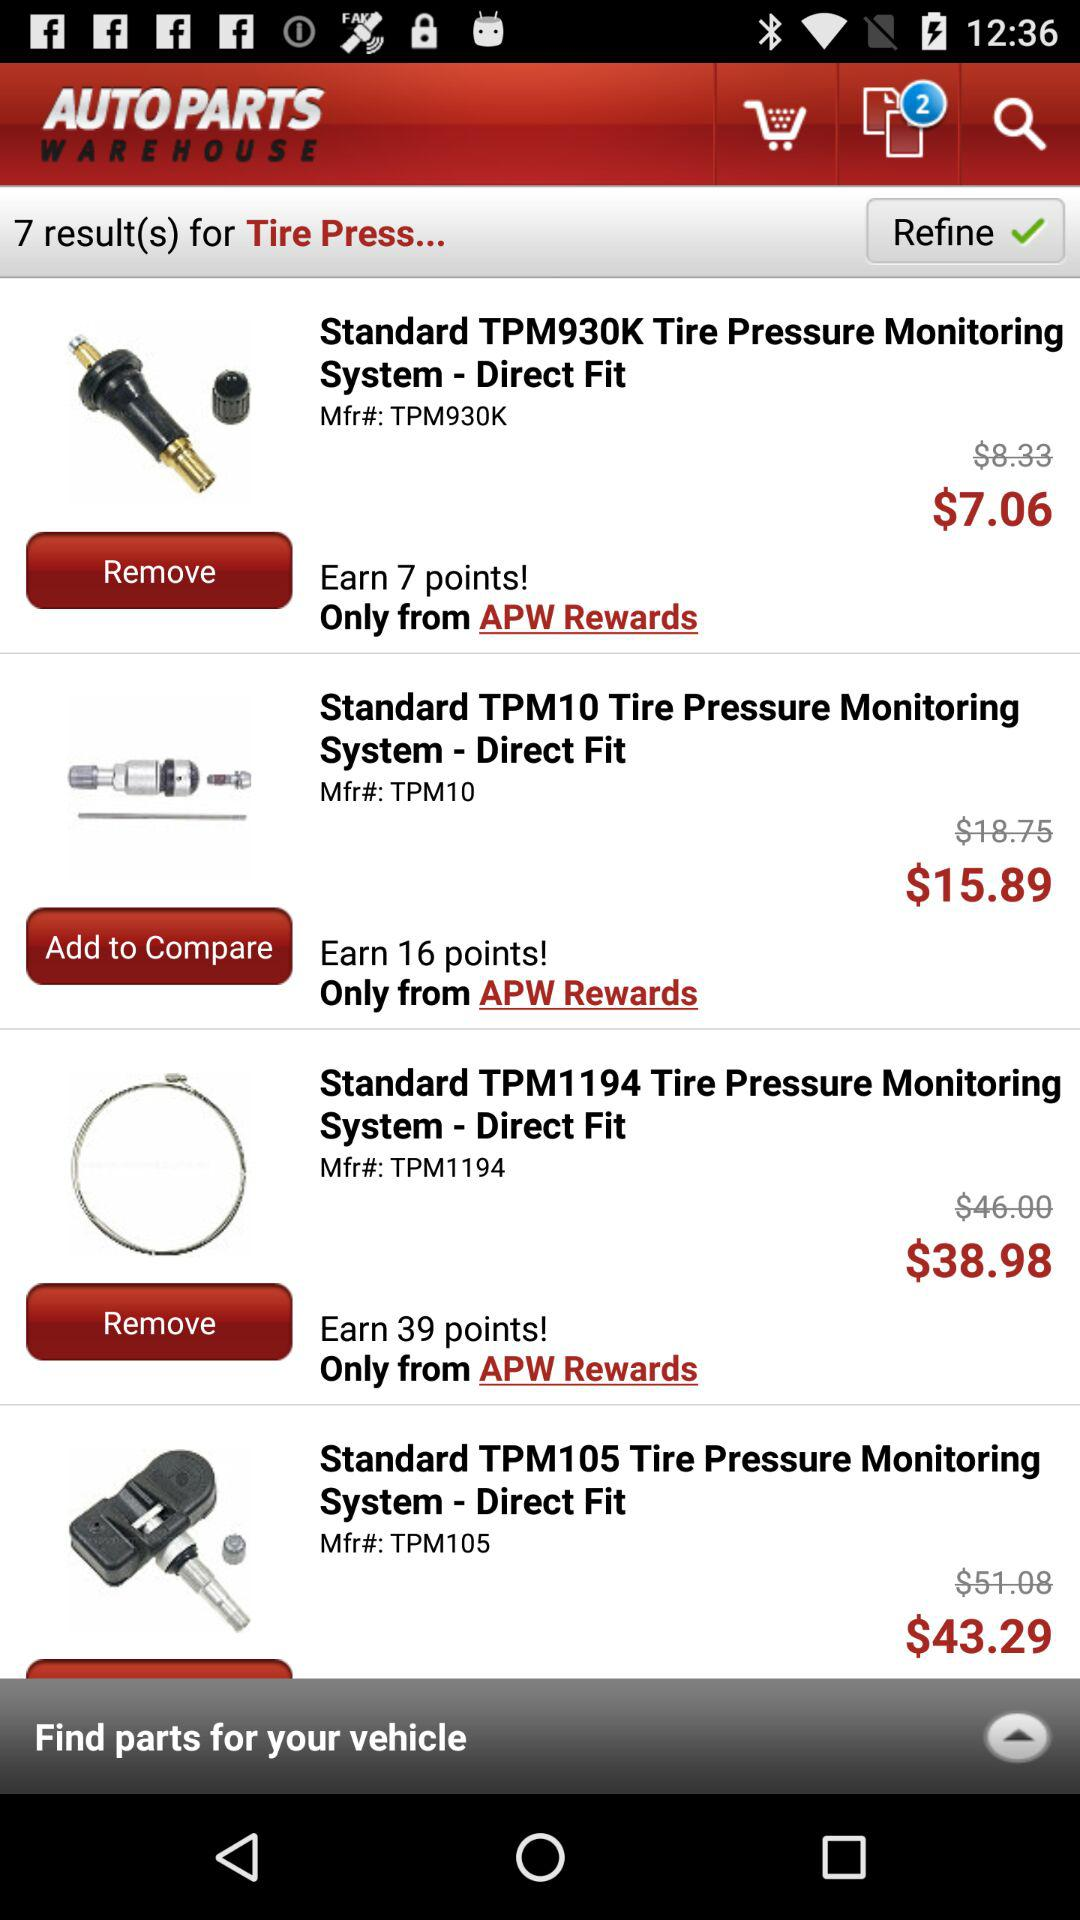How many tire pressure sensors are there in total?
Answer the question using a single word or phrase. 4 